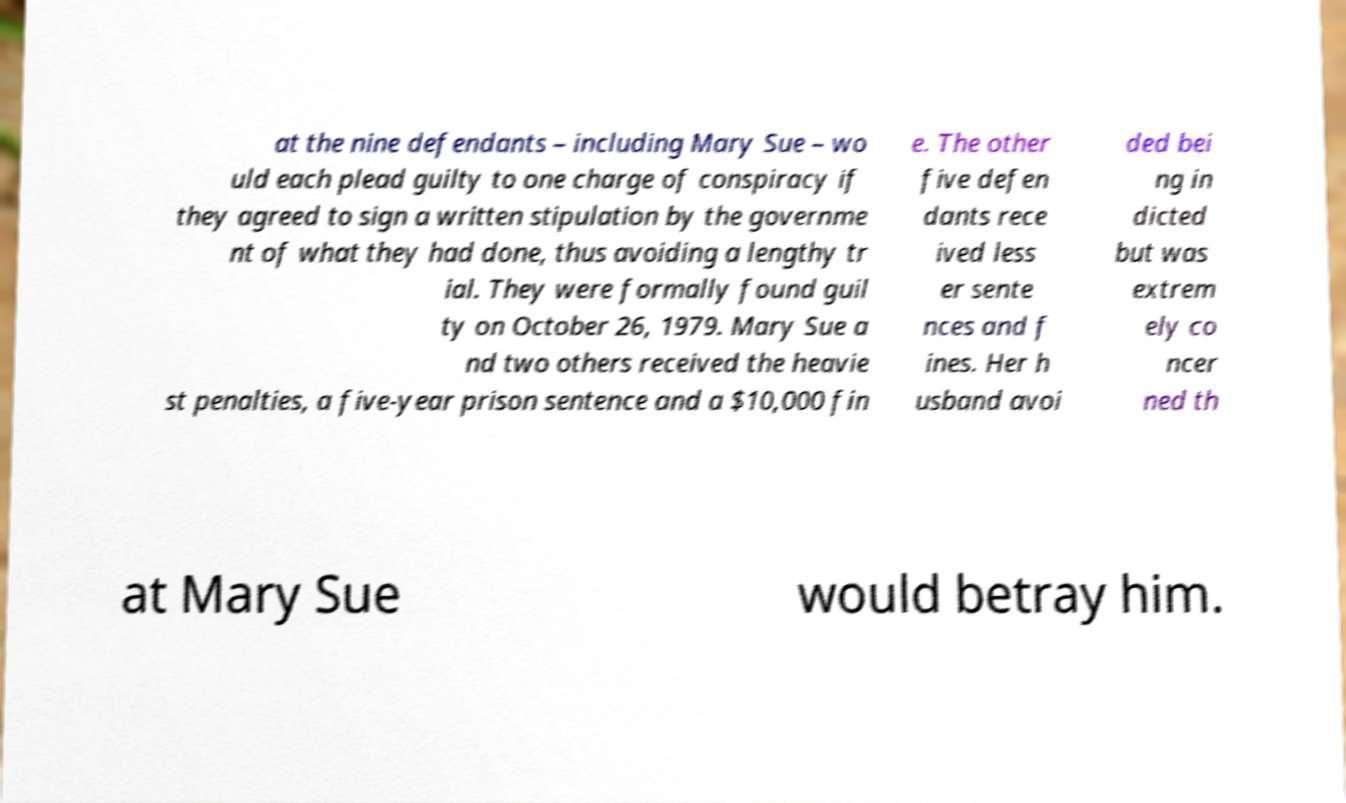Could you extract and type out the text from this image? at the nine defendants – including Mary Sue – wo uld each plead guilty to one charge of conspiracy if they agreed to sign a written stipulation by the governme nt of what they had done, thus avoiding a lengthy tr ial. They were formally found guil ty on October 26, 1979. Mary Sue a nd two others received the heavie st penalties, a five-year prison sentence and a $10,000 fin e. The other five defen dants rece ived less er sente nces and f ines. Her h usband avoi ded bei ng in dicted but was extrem ely co ncer ned th at Mary Sue would betray him. 